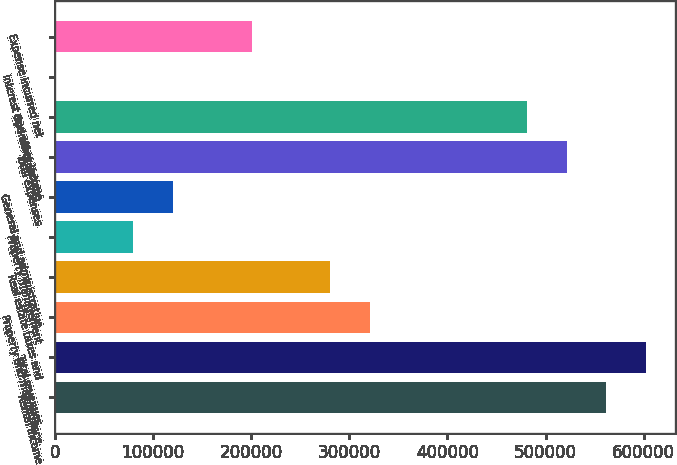Convert chart to OTSL. <chart><loc_0><loc_0><loc_500><loc_500><bar_chart><fcel>Rental income<fcel>Total revenues<fcel>Property and maintenance<fcel>Real estate taxes and<fcel>Property management<fcel>General and administrative<fcel>Total expenses<fcel>Operating income<fcel>Interest and other income<fcel>Expense incurred net<nl><fcel>561587<fcel>601700<fcel>320907<fcel>280794<fcel>80227.6<fcel>120341<fcel>521474<fcel>481361<fcel>1<fcel>200568<nl></chart> 